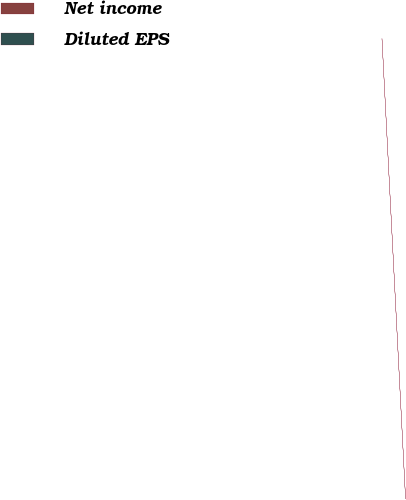Convert chart to OTSL. <chart><loc_0><loc_0><loc_500><loc_500><pie_chart><fcel>Net income<fcel>Diluted EPS<nl><fcel>100.0%<fcel>0.0%<nl></chart> 